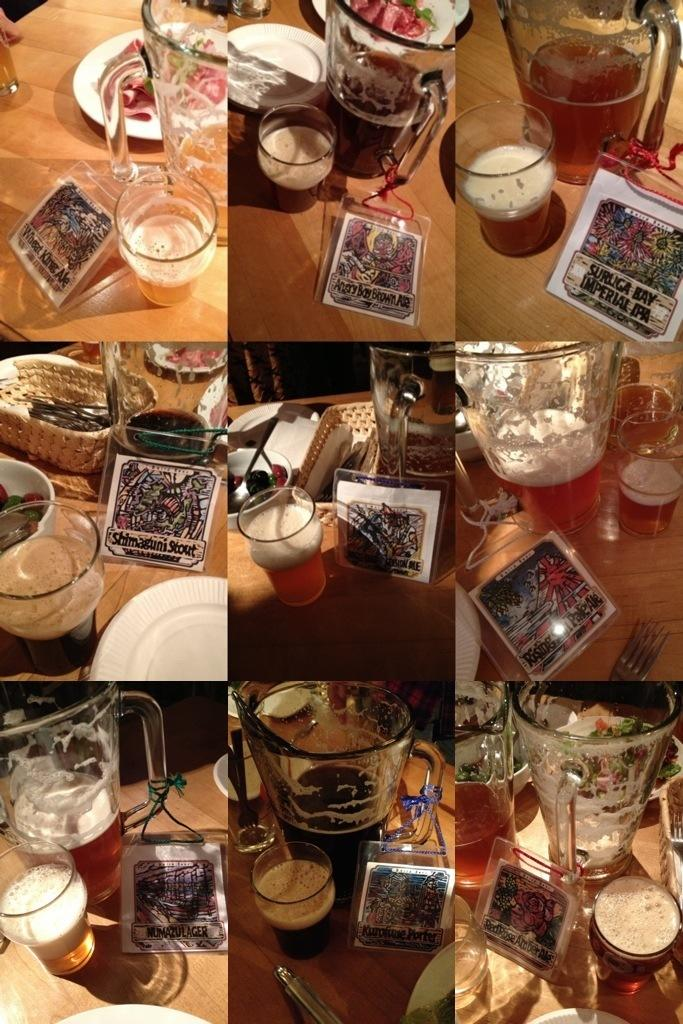What type of artwork is depicted in the image? The image is a collage. What objects can be seen in the collage? There are glasses, plates, and tables in the collage. What type of alarm can be heard in the image? There is no alarm present in the image, as it is a visual representation in the form of a collage. Can you touch the family in the image? There is no family depicted in the image, as it only features glasses, plates, and tables in a collage. 